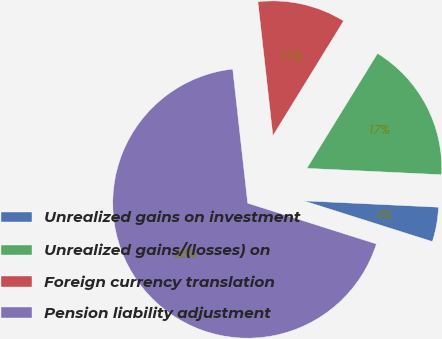Convert chart. <chart><loc_0><loc_0><loc_500><loc_500><pie_chart><fcel>Unrealized gains on investment<fcel>Unrealized gains/(losses) on<fcel>Foreign currency translation<fcel>Pension liability adjustment<nl><fcel>4.13%<fcel>16.97%<fcel>10.55%<fcel>68.34%<nl></chart> 